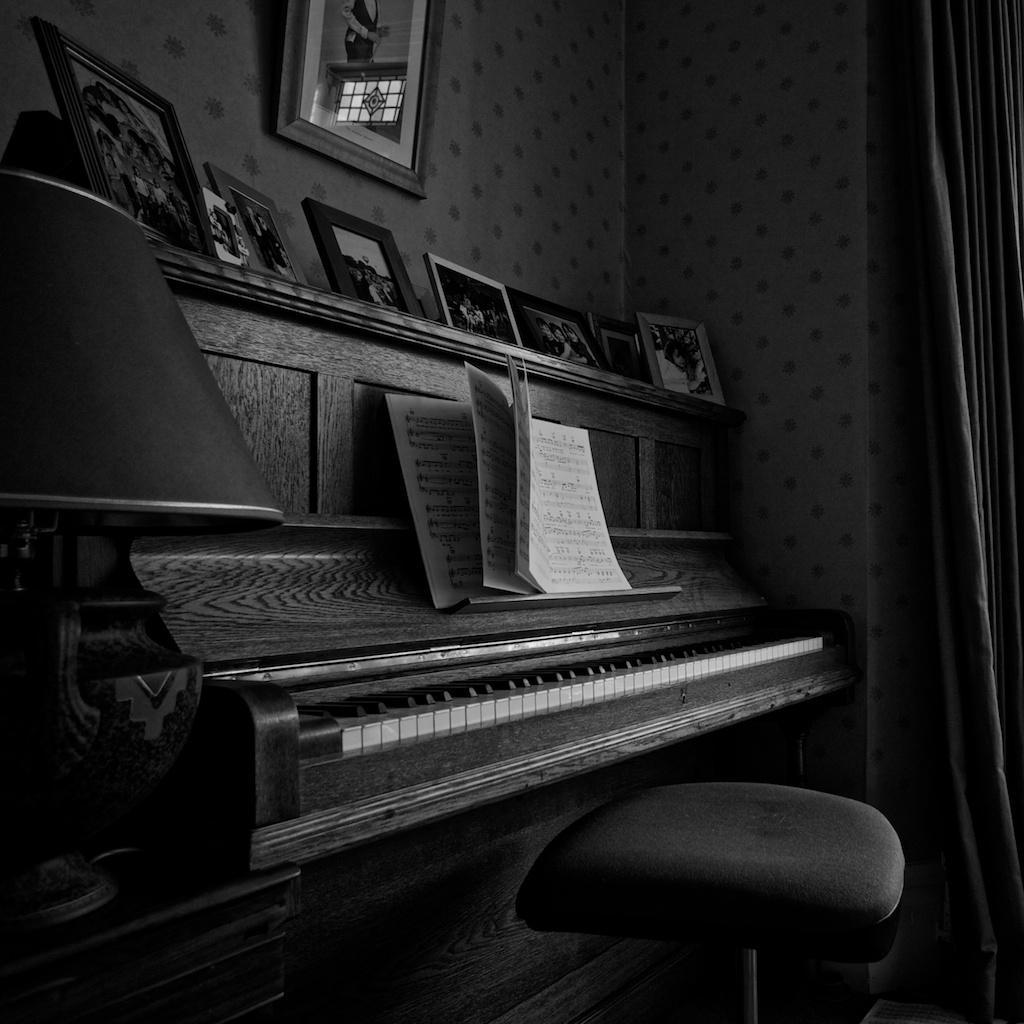How would you summarize this image in a sentence or two? Here we have photo frames or picture frames present. Behind the wooden desk we have piano desk, above piano we have a book seems like a music related one. Beside we have lamp and chair is present. It seems like musical room. 